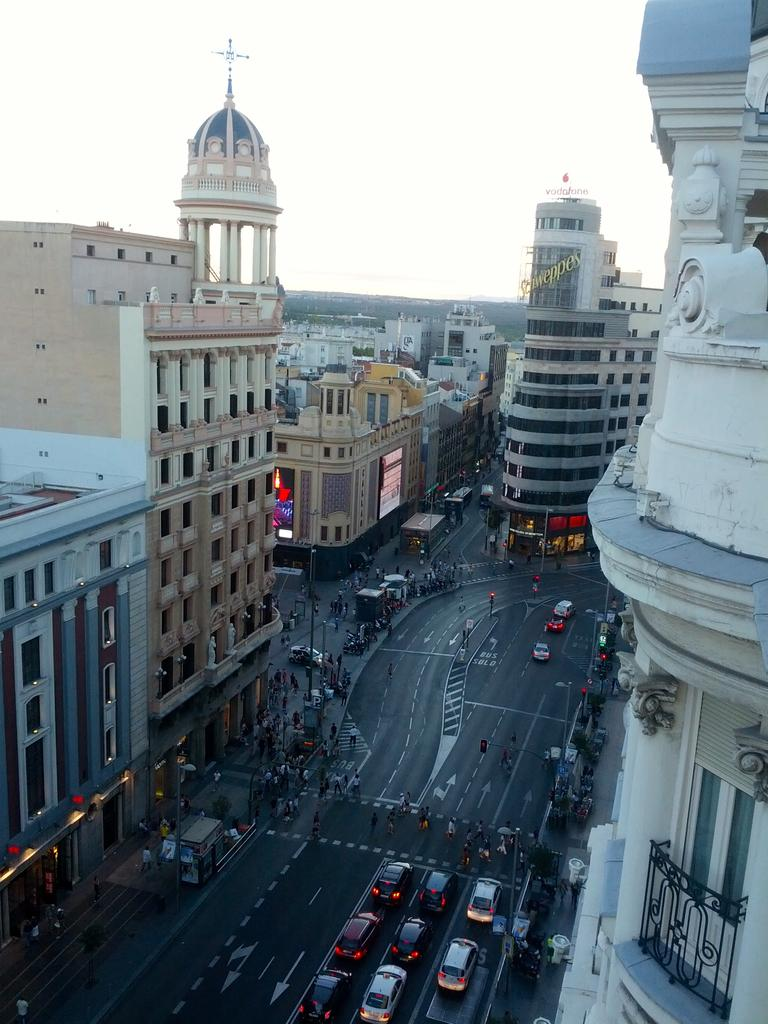What can be seen on the road in the image? There are vehicles on the road in the image. What type of structures are present in the image? There are buildings in the image. What objects can be seen supporting wires or signs in the image? There are poles in the image. What are the boards used for in the image? The boards might be used for advertising or displaying information in the image. Can you describe the people in the image? There are people in the image, but their specific actions or appearances are not mentioned in the provided facts. What is visible in the background of the image? The sky is visible in the background of the image. How does the hair of the people in the image affect the selection of vehicles on the road? There is no mention of hair or selection in the provided facts, and therefore these factors cannot be considered in relation to the vehicles on the road. 